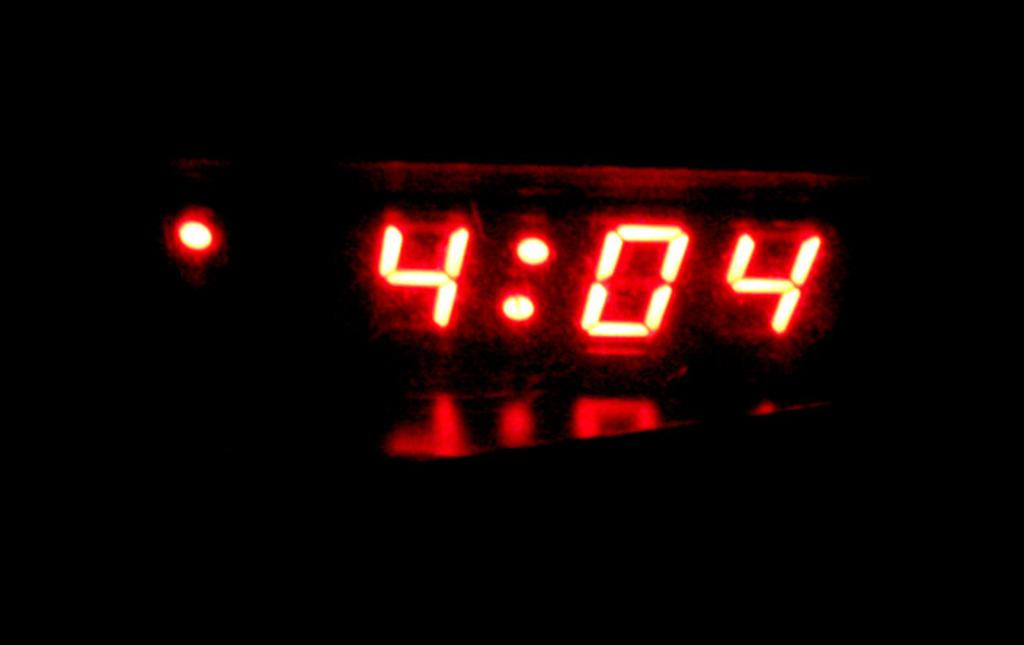<image>
Share a concise interpretation of the image provided. A digital clock which displays the time as 4:04 in glowing letters. 